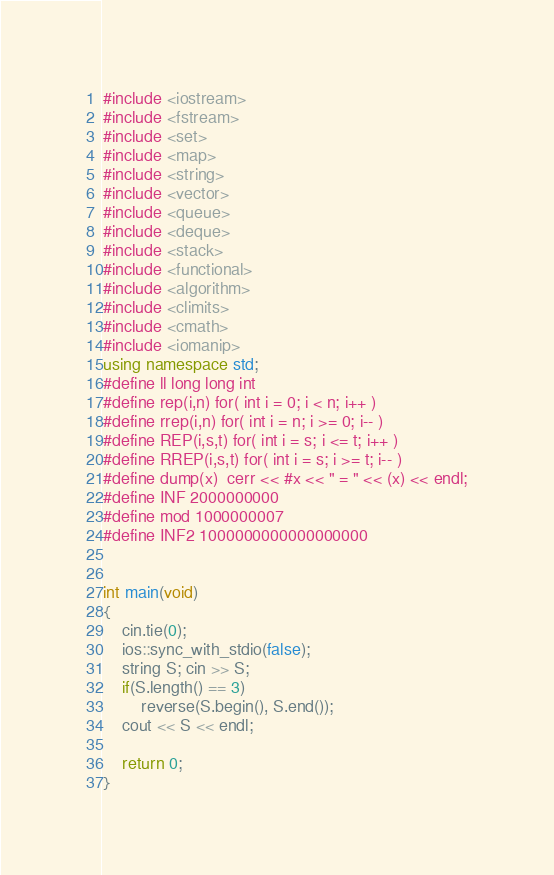<code> <loc_0><loc_0><loc_500><loc_500><_C++_>#include <iostream>
#include <fstream>
#include <set>
#include <map>
#include <string>
#include <vector>
#include <queue>
#include <deque>
#include <stack>
#include <functional>
#include <algorithm>
#include <climits>
#include <cmath>
#include <iomanip>
using namespace std;
#define ll long long int
#define rep(i,n) for( int i = 0; i < n; i++ )
#define rrep(i,n) for( int i = n; i >= 0; i-- )
#define REP(i,s,t) for( int i = s; i <= t; i++ )
#define RREP(i,s,t) for( int i = s; i >= t; i-- )
#define dump(x)  cerr << #x << " = " << (x) << endl;
#define INF 2000000000
#define mod 1000000007
#define INF2 1000000000000000000


int main(void)
{
    cin.tie(0);
    ios::sync_with_stdio(false);
    string S; cin >> S;
    if(S.length() == 3)
        reverse(S.begin(), S.end());
    cout << S << endl;

    return 0;
}
</code> 